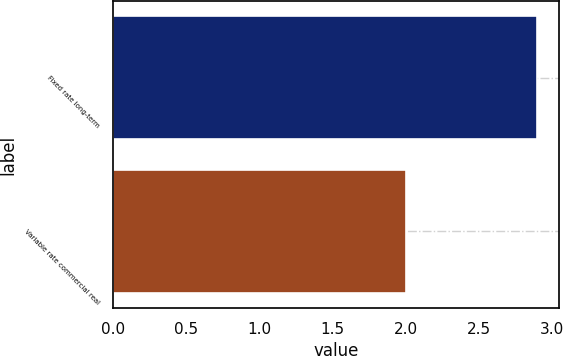<chart> <loc_0><loc_0><loc_500><loc_500><bar_chart><fcel>Fixed rate long-term<fcel>Variable rate commercial real<nl><fcel>2.9<fcel>2<nl></chart> 